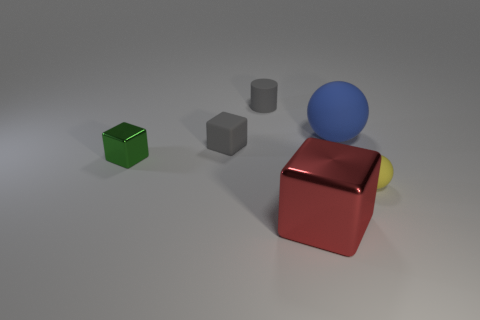Add 4 blue rubber things. How many objects exist? 10 Subtract all balls. How many objects are left? 4 Add 2 large brown rubber cubes. How many large brown rubber cubes exist? 2 Subtract 0 yellow cylinders. How many objects are left? 6 Subtract all tiny green shiny cubes. Subtract all green metallic cubes. How many objects are left? 4 Add 1 tiny balls. How many tiny balls are left? 2 